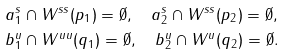<formula> <loc_0><loc_0><loc_500><loc_500>& a _ { 1 } ^ { s } \cap W ^ { s s } ( p _ { 1 } ) = \emptyset , \quad a _ { 2 } ^ { s } \cap W ^ { s s } ( p _ { 2 } ) = \emptyset , \\ & b _ { 1 } ^ { u } \cap W ^ { u u } ( q _ { 1 } ) = \emptyset , \quad b _ { 2 } ^ { u } \cap W ^ { u } ( q _ { 2 } ) = \emptyset .</formula> 